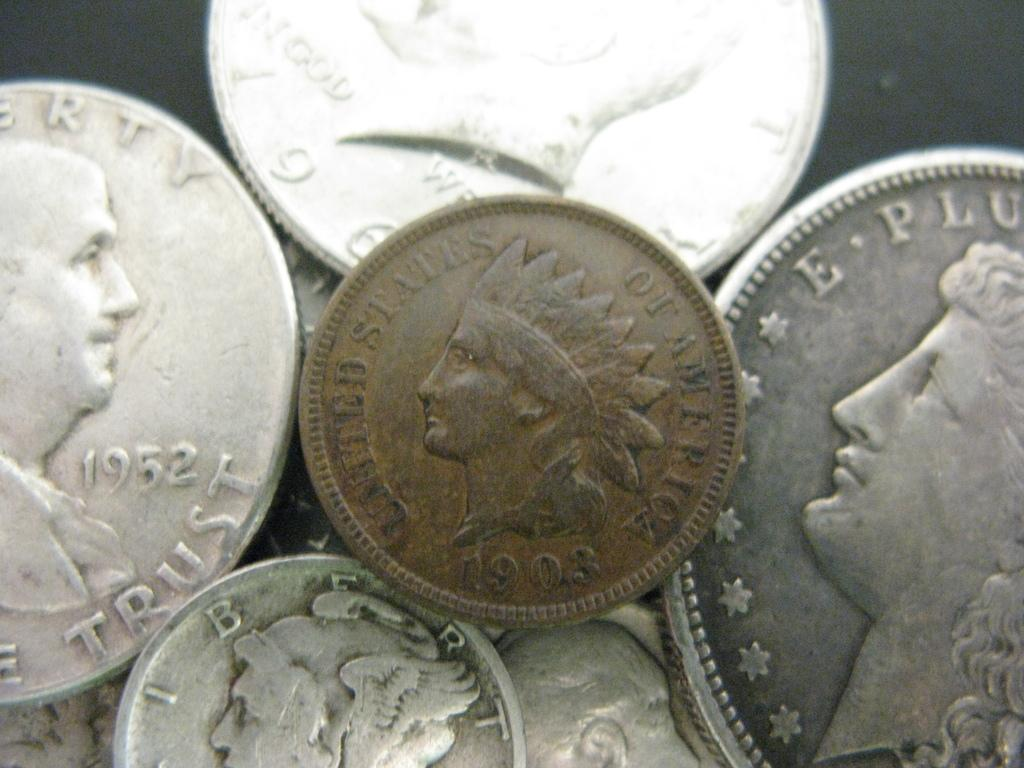<image>
Describe the image concisely. The year on the silver coin in the back is 1952 